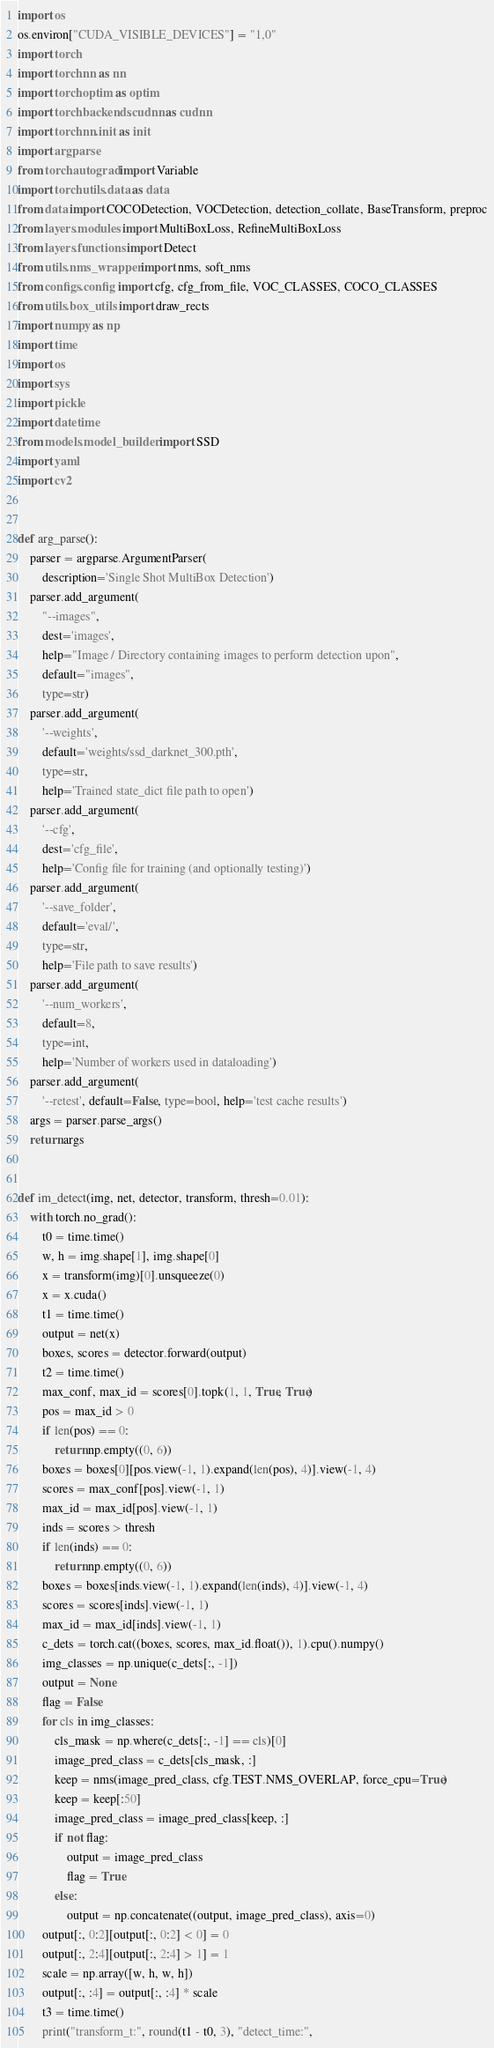<code> <loc_0><loc_0><loc_500><loc_500><_Python_>import os
os.environ["CUDA_VISIBLE_DEVICES"] = "1,0"
import torch
import torch.nn as nn
import torch.optim as optim
import torch.backends.cudnn as cudnn
import torch.nn.init as init
import argparse
from torch.autograd import Variable
import torch.utils.data as data
from data import COCODetection, VOCDetection, detection_collate, BaseTransform, preproc
from layers.modules import MultiBoxLoss, RefineMultiBoxLoss
from layers.functions import Detect
from utils.nms_wrapper import nms, soft_nms
from configs.config import cfg, cfg_from_file, VOC_CLASSES, COCO_CLASSES
from utils.box_utils import draw_rects
import numpy as np
import time
import os
import sys
import pickle
import datetime
from models.model_builder import SSD
import yaml
import cv2


def arg_parse():
    parser = argparse.ArgumentParser(
        description='Single Shot MultiBox Detection')
    parser.add_argument(
        "--images",
        dest='images',
        help="Image / Directory containing images to perform detection upon",
        default="images",
        type=str)
    parser.add_argument(
        '--weights',
        default='weights/ssd_darknet_300.pth',
        type=str,
        help='Trained state_dict file path to open')
    parser.add_argument(
        '--cfg',
        dest='cfg_file',
        help='Config file for training (and optionally testing)')
    parser.add_argument(
        '--save_folder',
        default='eval/',
        type=str,
        help='File path to save results')
    parser.add_argument(
        '--num_workers',
        default=8,
        type=int,
        help='Number of workers used in dataloading')
    parser.add_argument(
        '--retest', default=False, type=bool, help='test cache results')
    args = parser.parse_args()
    return args


def im_detect(img, net, detector, transform, thresh=0.01):
    with torch.no_grad():
        t0 = time.time()
        w, h = img.shape[1], img.shape[0]
        x = transform(img)[0].unsqueeze(0)
        x = x.cuda()
        t1 = time.time()
        output = net(x)
        boxes, scores = detector.forward(output)
        t2 = time.time()
        max_conf, max_id = scores[0].topk(1, 1, True, True)
        pos = max_id > 0
        if len(pos) == 0:
            return np.empty((0, 6))
        boxes = boxes[0][pos.view(-1, 1).expand(len(pos), 4)].view(-1, 4)
        scores = max_conf[pos].view(-1, 1)
        max_id = max_id[pos].view(-1, 1)
        inds = scores > thresh
        if len(inds) == 0:
            return np.empty((0, 6))
        boxes = boxes[inds.view(-1, 1).expand(len(inds), 4)].view(-1, 4)
        scores = scores[inds].view(-1, 1)
        max_id = max_id[inds].view(-1, 1)
        c_dets = torch.cat((boxes, scores, max_id.float()), 1).cpu().numpy()
        img_classes = np.unique(c_dets[:, -1])
        output = None
        flag = False
        for cls in img_classes:
            cls_mask = np.where(c_dets[:, -1] == cls)[0]
            image_pred_class = c_dets[cls_mask, :]
            keep = nms(image_pred_class, cfg.TEST.NMS_OVERLAP, force_cpu=True)
            keep = keep[:50]
            image_pred_class = image_pred_class[keep, :]
            if not flag:
                output = image_pred_class
                flag = True
            else:
                output = np.concatenate((output, image_pred_class), axis=0)
        output[:, 0:2][output[:, 0:2] < 0] = 0
        output[:, 2:4][output[:, 2:4] > 1] = 1
        scale = np.array([w, h, w, h])
        output[:, :4] = output[:, :4] * scale
        t3 = time.time()
        print("transform_t:", round(t1 - t0, 3), "detect_time:",</code> 